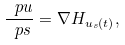Convert formula to latex. <formula><loc_0><loc_0><loc_500><loc_500>\frac { \ p u } { \ p s } = \nabla H _ { { u _ { s } } ( t ) } ,</formula> 